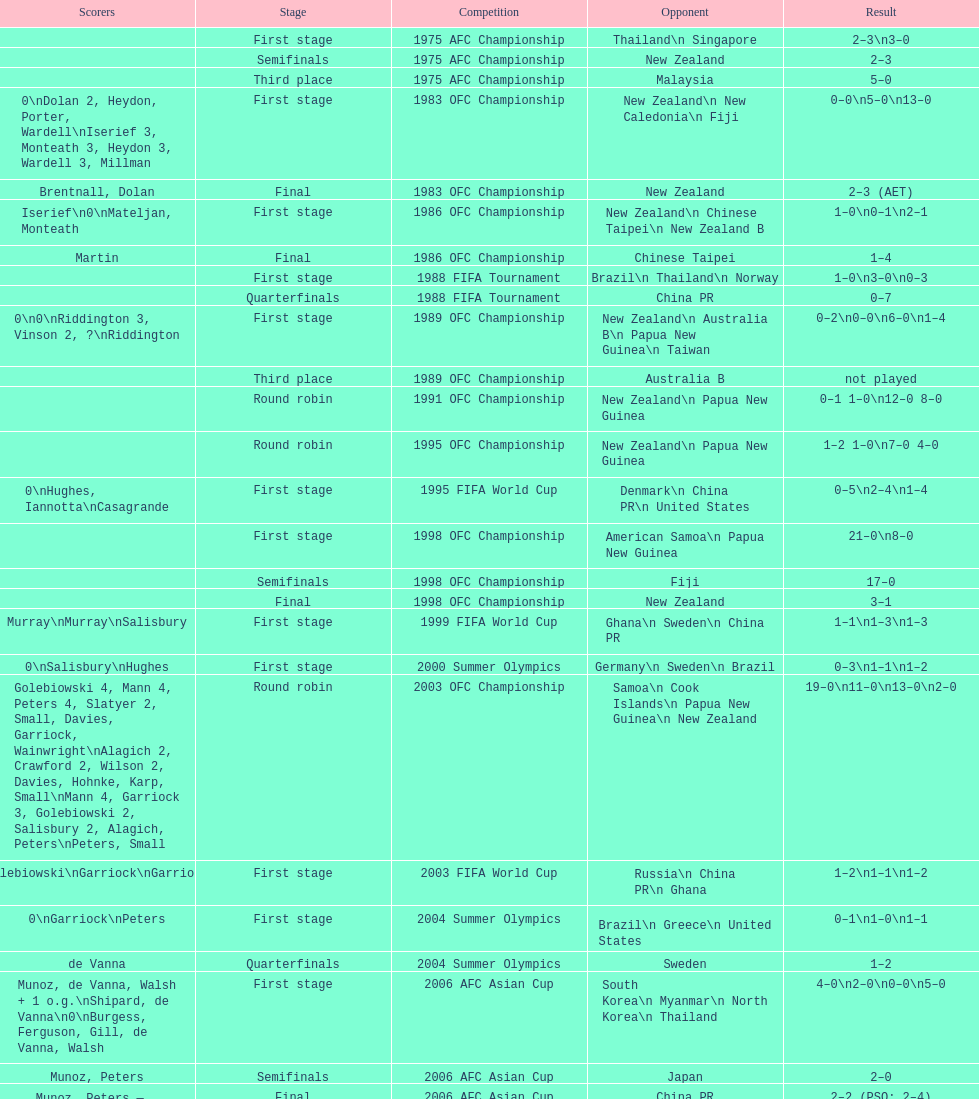What was the total goals made in the 1983 ofc championship? 18. 